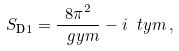<formula> <loc_0><loc_0><loc_500><loc_500>S _ { \text {D} 1 } = \frac { 8 \pi ^ { 2 } } { \ g y m } - i \ t y m \, ,</formula> 